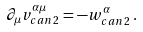<formula> <loc_0><loc_0><loc_500><loc_500>\partial _ { \mu } v ^ { \alpha \mu } _ { c a n \, 2 } = - w ^ { \alpha } _ { c a n \, 2 } \, .</formula> 